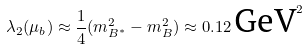<formula> <loc_0><loc_0><loc_500><loc_500>\lambda _ { 2 } ( \mu _ { b } ) \approx \frac { 1 } { 4 } ( m _ { B ^ { * } } ^ { 2 } - m _ { B } ^ { 2 } ) \approx 0 . 1 2 \, \text {GeV} ^ { 2 }</formula> 